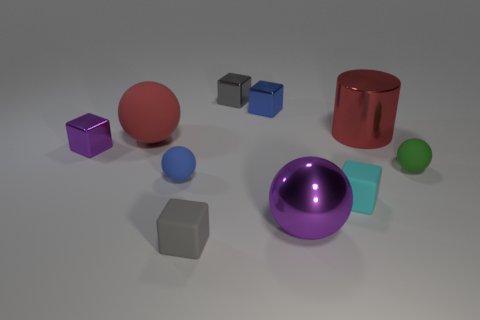Is the color of the tiny rubber sphere that is in front of the tiny green rubber ball the same as the cylinder?
Your answer should be very brief. No. How many things are either small cubes that are to the right of the red rubber sphere or big cyan matte balls?
Offer a very short reply. 4. There is a small sphere left of the purple sphere that is in front of the cylinder that is on the right side of the small purple metallic object; what is it made of?
Provide a succinct answer. Rubber. Are there more tiny blue metallic cubes in front of the small green thing than cyan blocks behind the big shiny sphere?
Provide a short and direct response. No. What number of cylinders are either tiny cyan rubber things or gray rubber objects?
Make the answer very short. 0. There is a rubber ball right of the large ball that is in front of the large red ball; what number of gray shiny blocks are right of it?
Offer a terse response. 0. There is a large object that is the same color as the cylinder; what material is it?
Provide a succinct answer. Rubber. Are there more gray matte cubes than things?
Ensure brevity in your answer.  No. Does the red metal cylinder have the same size as the green sphere?
Offer a very short reply. No. How many things are blue metal cylinders or shiny blocks?
Keep it short and to the point. 3. 